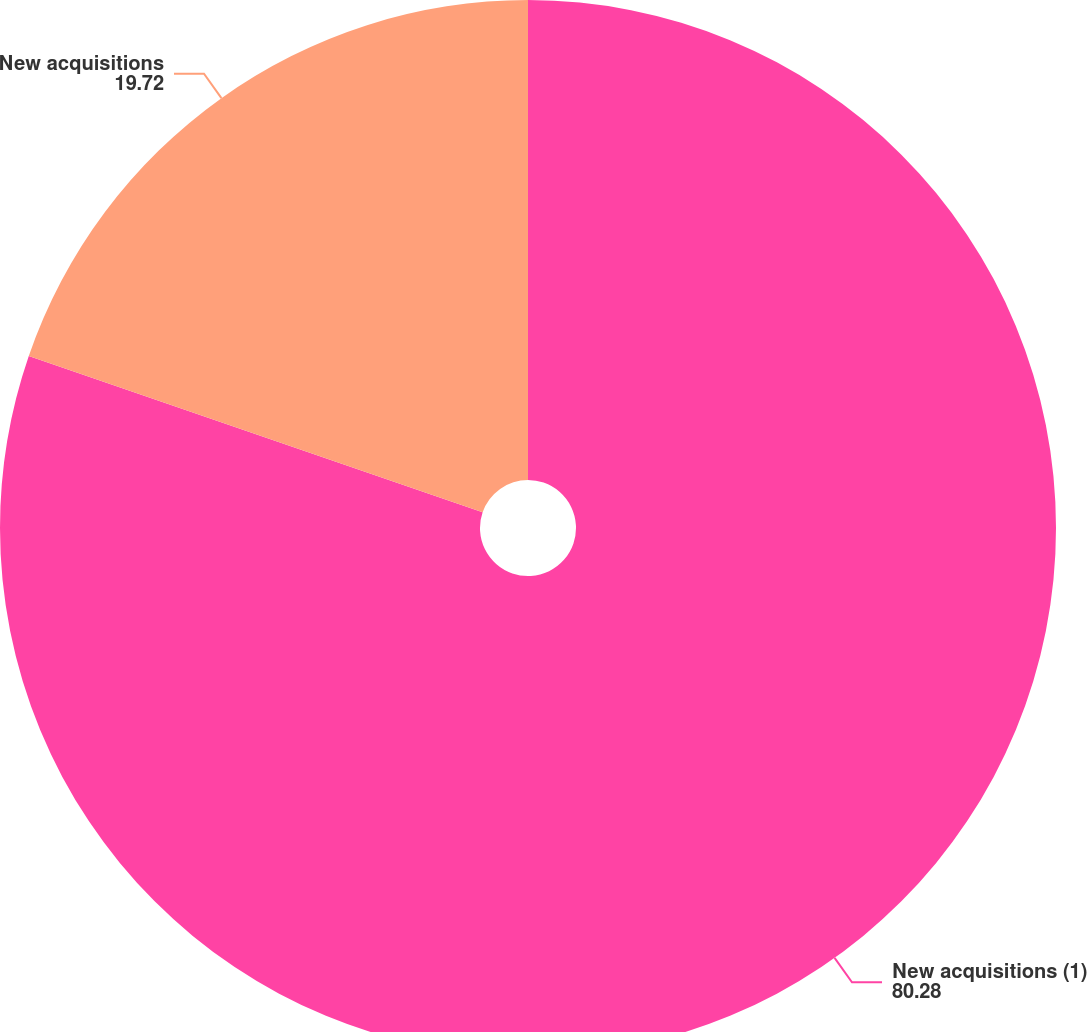Convert chart. <chart><loc_0><loc_0><loc_500><loc_500><pie_chart><fcel>New acquisitions (1)<fcel>New acquisitions<nl><fcel>80.28%<fcel>19.72%<nl></chart> 